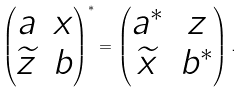<formula> <loc_0><loc_0><loc_500><loc_500>\begin{pmatrix} a & x \\ \widetilde { z } & b \end{pmatrix} ^ { * } = \begin{pmatrix} a ^ { * } & z \\ \widetilde { x } & b ^ { * } \end{pmatrix} .</formula> 